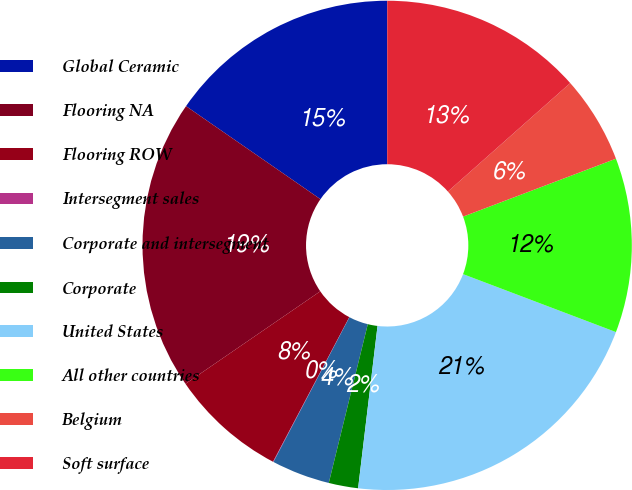Convert chart to OTSL. <chart><loc_0><loc_0><loc_500><loc_500><pie_chart><fcel>Global Ceramic<fcel>Flooring NA<fcel>Flooring ROW<fcel>Intersegment sales<fcel>Corporate and intersegment<fcel>Corporate<fcel>United States<fcel>All other countries<fcel>Belgium<fcel>Soft surface<nl><fcel>15.37%<fcel>19.21%<fcel>7.7%<fcel>0.03%<fcel>3.86%<fcel>1.94%<fcel>21.13%<fcel>11.53%<fcel>5.78%<fcel>13.45%<nl></chart> 